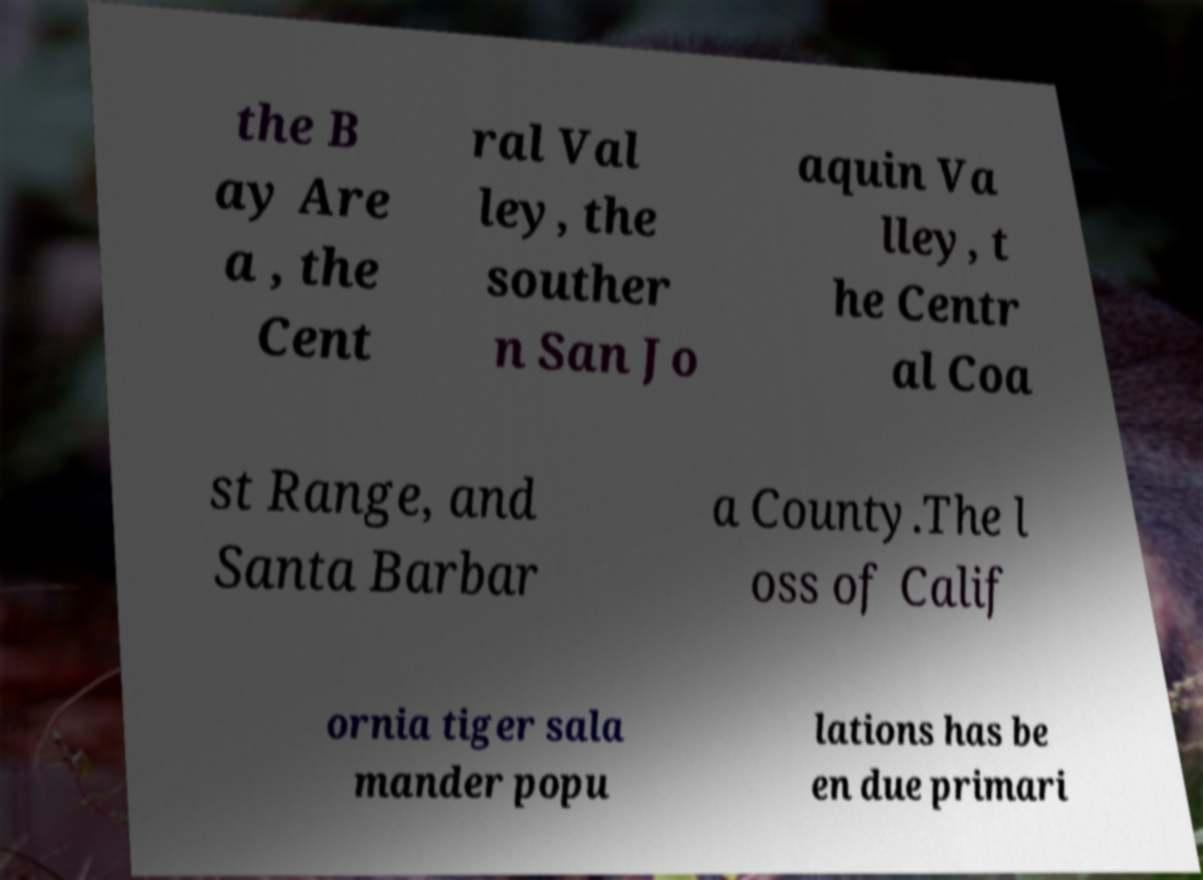I need the written content from this picture converted into text. Can you do that? the B ay Are a , the Cent ral Val ley, the souther n San Jo aquin Va lley, t he Centr al Coa st Range, and Santa Barbar a County.The l oss of Calif ornia tiger sala mander popu lations has be en due primari 